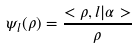Convert formula to latex. <formula><loc_0><loc_0><loc_500><loc_500>\psi _ { l } ( \rho ) = \frac { < \rho , l | \alpha > } \rho</formula> 